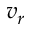<formula> <loc_0><loc_0><loc_500><loc_500>v _ { r }</formula> 